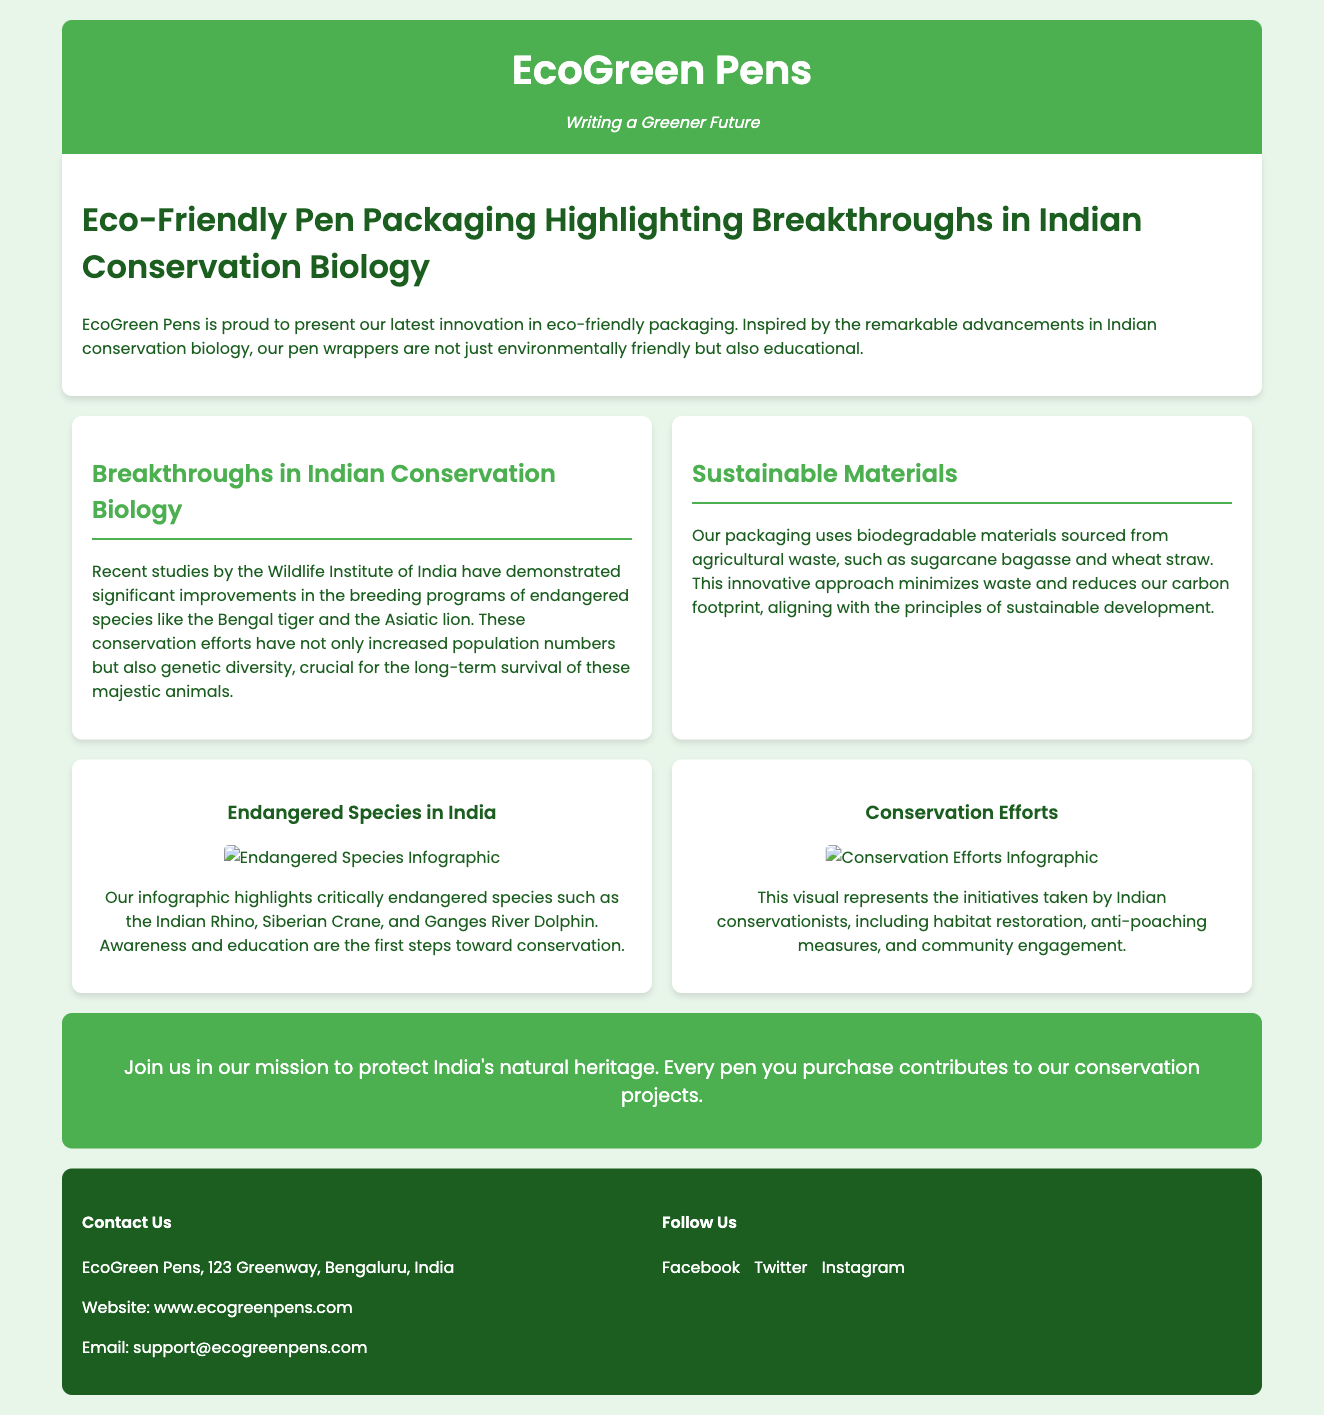What is the company name? The company name is prominently displayed at the top of the document in the logo section.
Answer: EcoGreen Pens What is the slogan of EcoGreen Pens? The slogan is featured directly beneath the company name and reflects the company's vision.
Answer: Writing a Greener Future What materials are used for packaging? The materials used for packaging are mentioned in the section discussing sustainable practices.
Answer: Biodegradable materials How many endangered species are highlighted in the infographic? The infographic on endangered species mentions specific critically endangered animals.
Answer: Three What does the infographic on conservation efforts display? The infographic describes the various initiatives taken by conservationists in India.
Answer: Initiatives taken by Indian conservationists What is the main purpose of purchasing the pens? The document promotes a mission linked to conservation projects with each pen sold.
Answer: Contributes to conservation projects Where is EcoGreen Pens located? The location of the company is stated in the contact information section of the footer.
Answer: Bengaluru, India How can you contact EcoGreen Pens? The contact information provides a specific email address for customer inquiries.
Answer: support@ecogreenpens.com What is the main focus of the introduction section? The introduction outlines the innovative approach EcoGreen Pens takes with its packaging and its connection to Indian conservation.
Answer: Eco-friendly packaging and education 